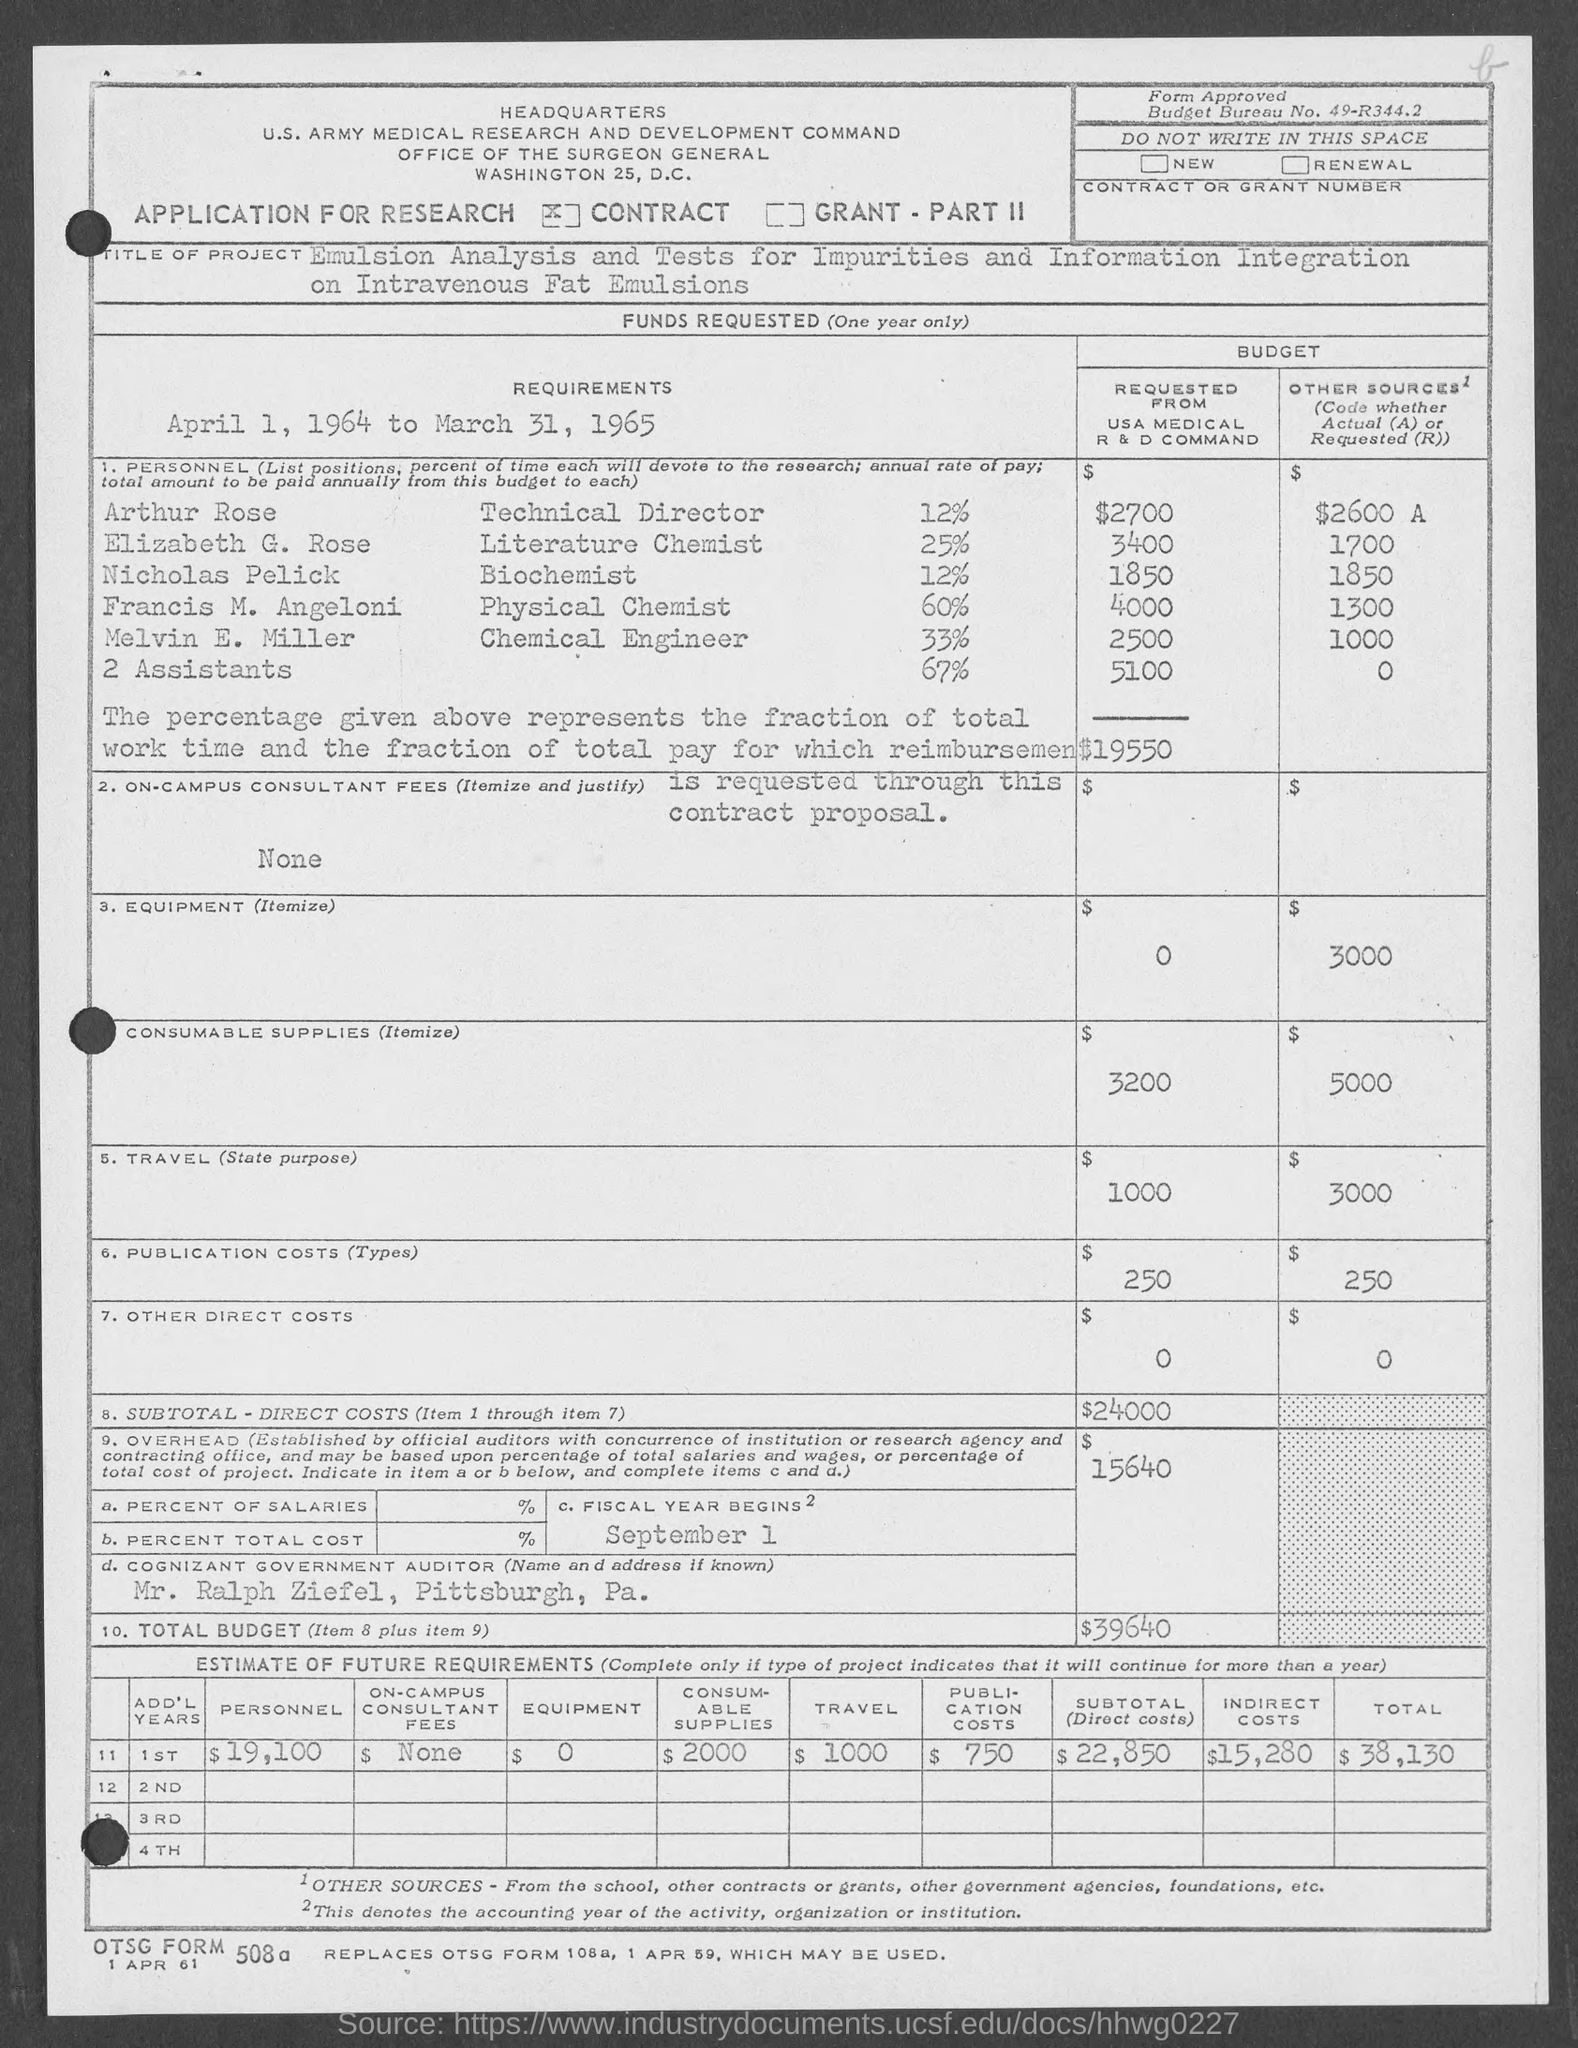What are the requirements?
Make the answer very short. April 1, 1964 to March 31, 1965. What is the Budget requested from USA Medical R & D Command by Arthur Rose?
Provide a short and direct response. 2700. What is the Budget requested from USA Medical R & D Command by Elizabeth G. Rose?
Offer a terse response. 3400. What is the Budget requested from USA Medical R & D Command by Nicholas Pelick?
Provide a short and direct response. 1850. What is the Budget requested from USA Medical R & D Command by Francis M. Angeloni?
Keep it short and to the point. 4000. What is the Budget requested from USA Medical R & D Command by Melvin E. Miller?
Offer a terse response. 2500. What is the Budget requested from USA Medical R & D Command by 2 Assistants?
Your answer should be very brief. 5100. What is the subtotal - direct costs?
Provide a succinct answer. 24000. The fiscal year begins when?
Provide a short and direct response. September 1. What is the Total Budget?
Keep it short and to the point. 39640. 